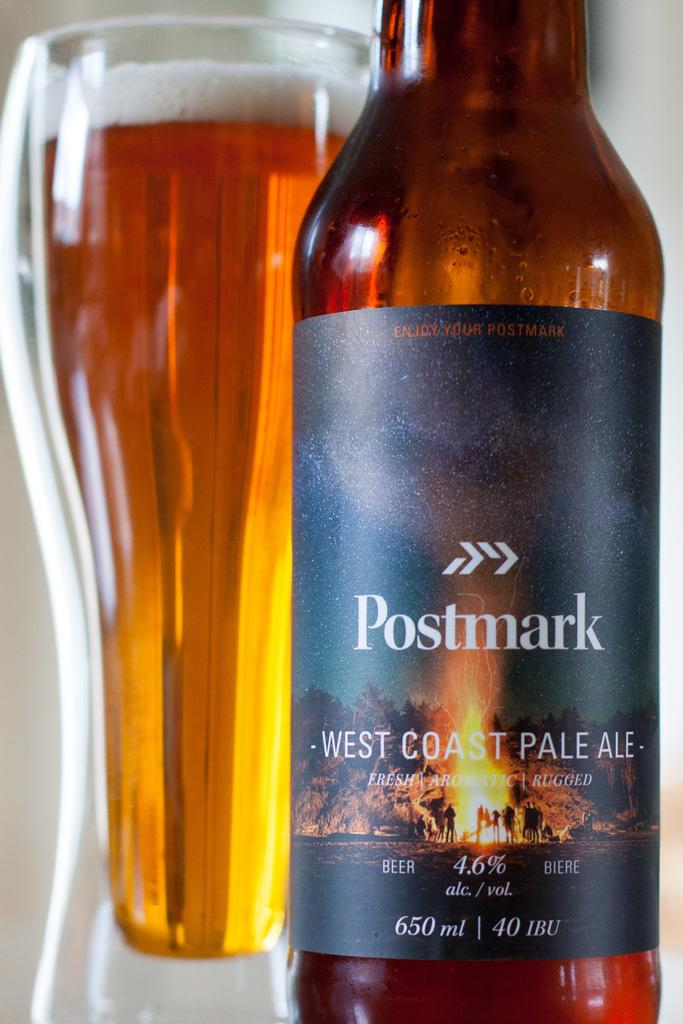<image>
Summarize the visual content of the image. A Postmark brand bottle of pale ale sits next to a full glass. 